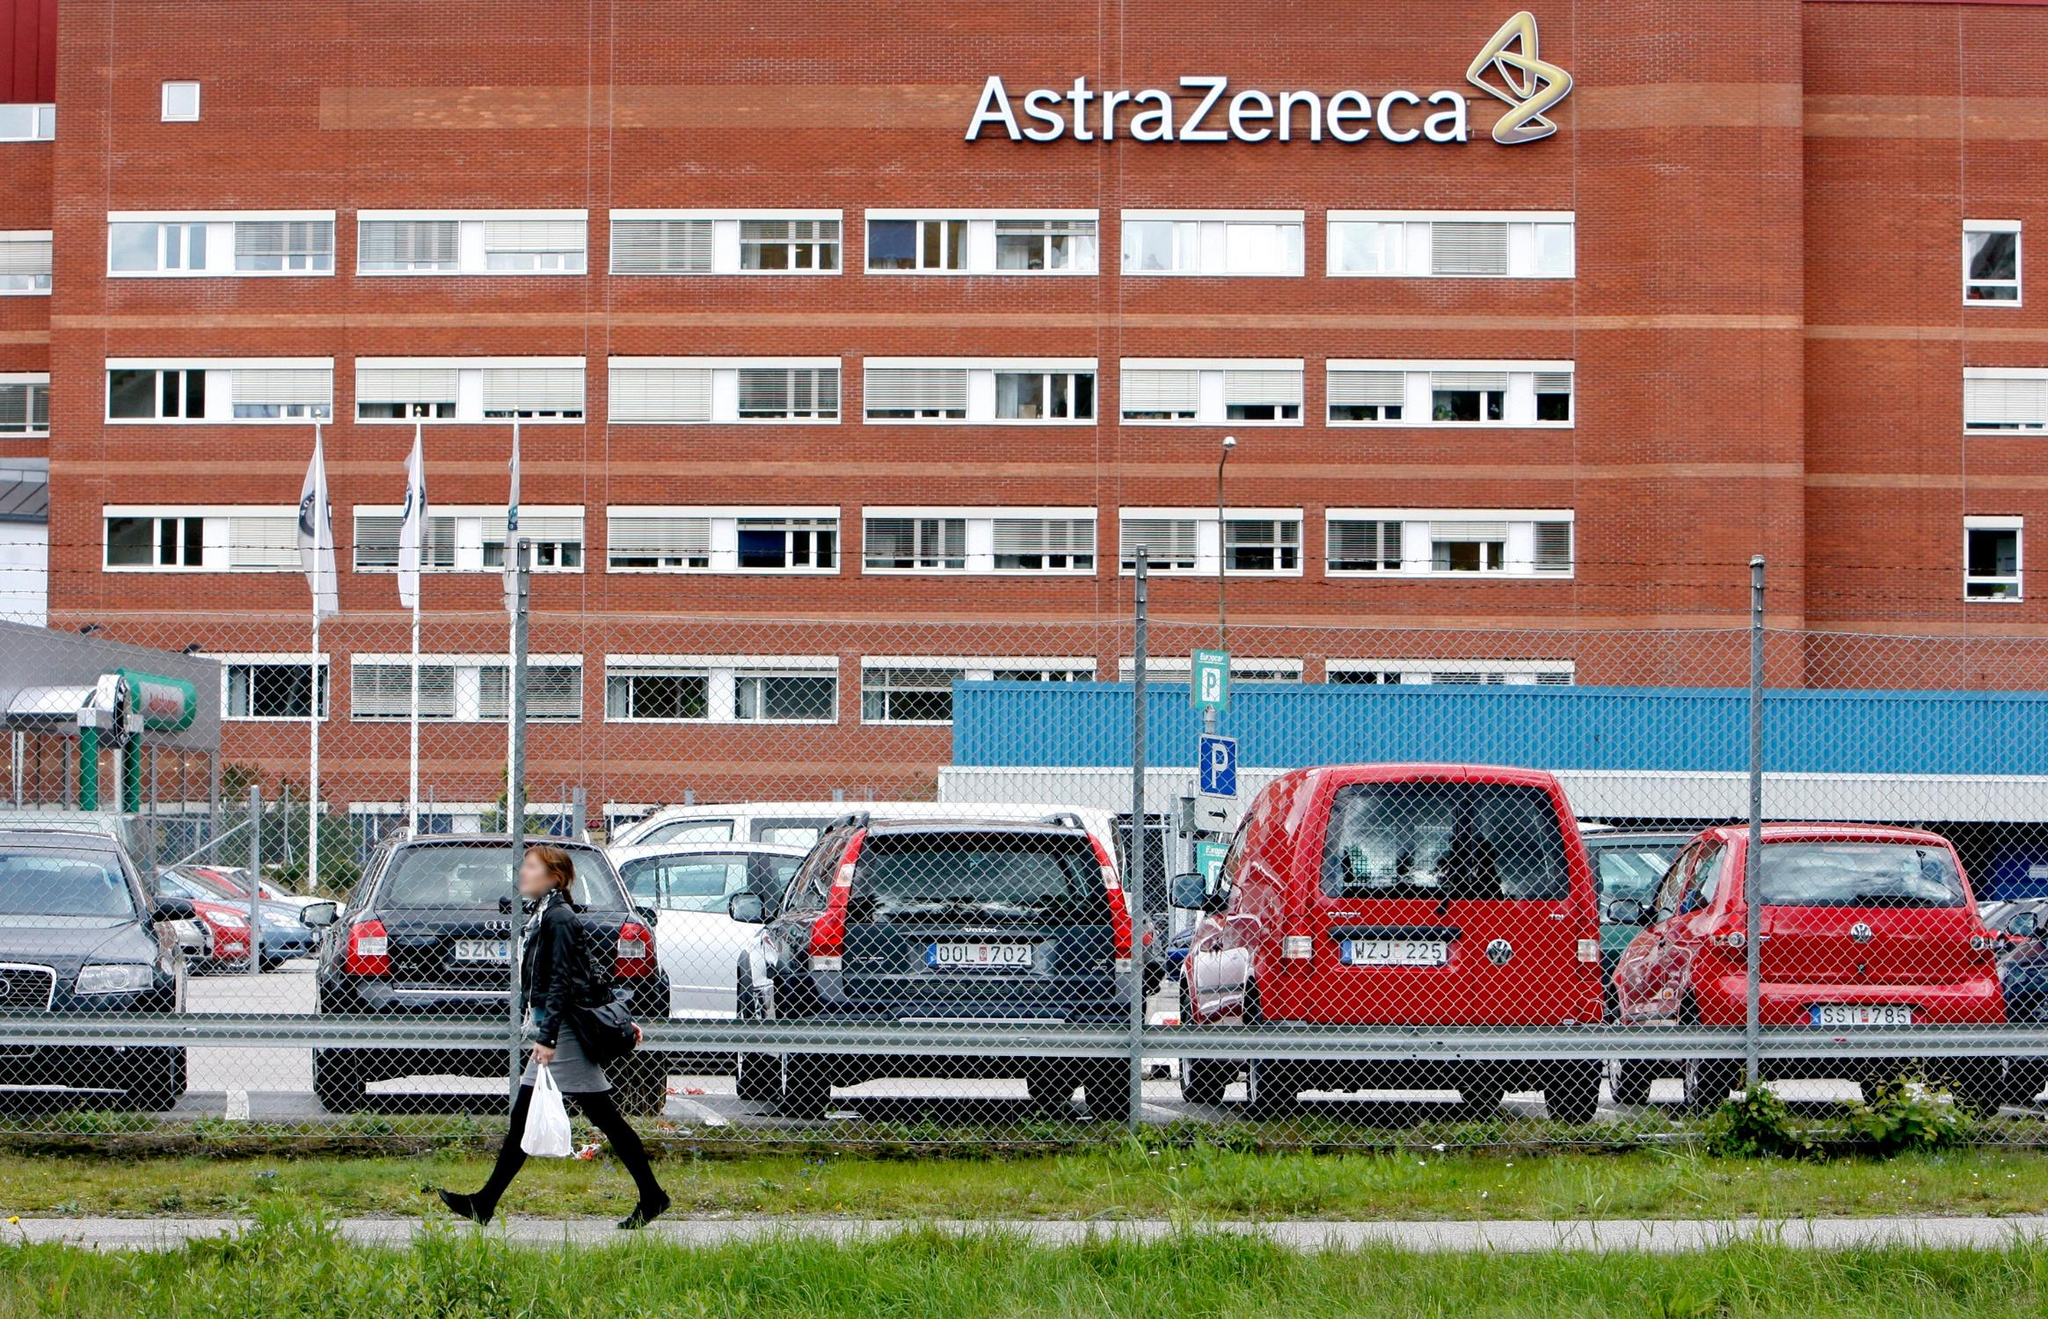If the building could talk, what stories might it tell? If the AstraZeneca building could speak, it might share tales of groundbreaking research and the development of life-saving medications. It could recount the countless hours spent by dedicated scientists and researchers working tirelessly to push the boundaries of medical knowledge. The building might describe the anticipation of major product launches, the joy of clinical breakthroughs, and the occasional heartbreak of setbacks in the lab. It could also tell stories of high-profile visits from stakeholders and international collaborations, all aimed at advancing global health. Additionally, quieter moments of everyday life, like employees sharing coffee breaks or brainstorming sessions that sparked innovative ideas, would weave a rich tapestry of life within its walls. 